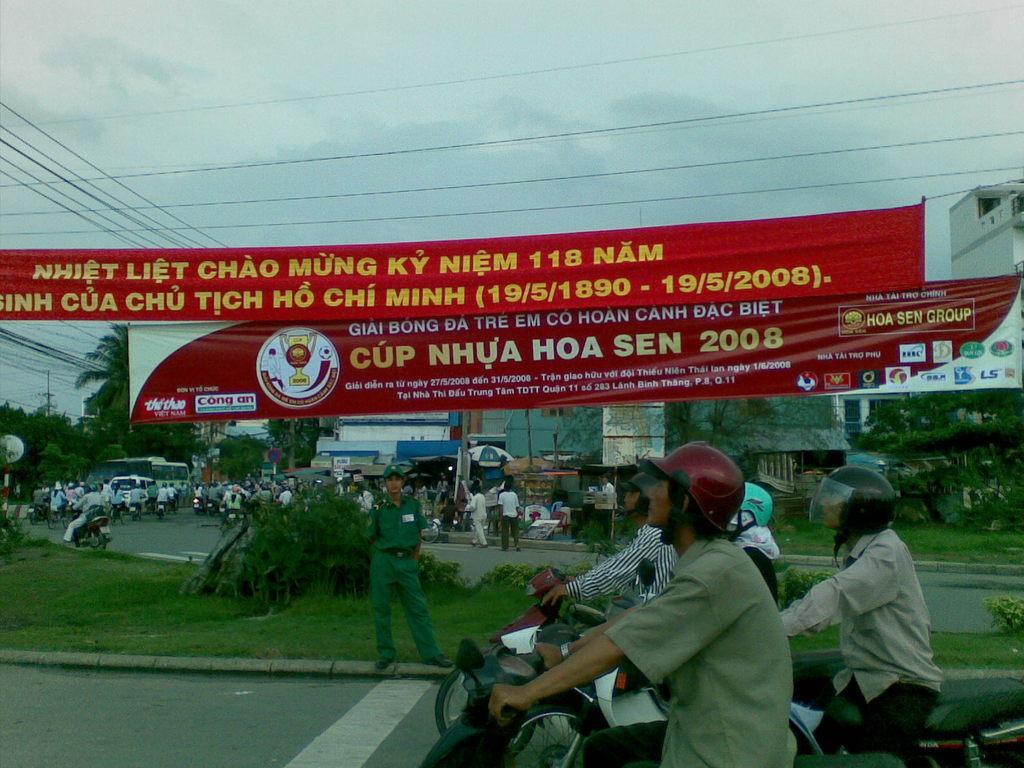Could you give a brief overview of what you see in this image? In this picture we can see bikes on the road with some people sitting on it, banners, grass, trees, buildings, wires, some objects and in the background we can see the sky. 